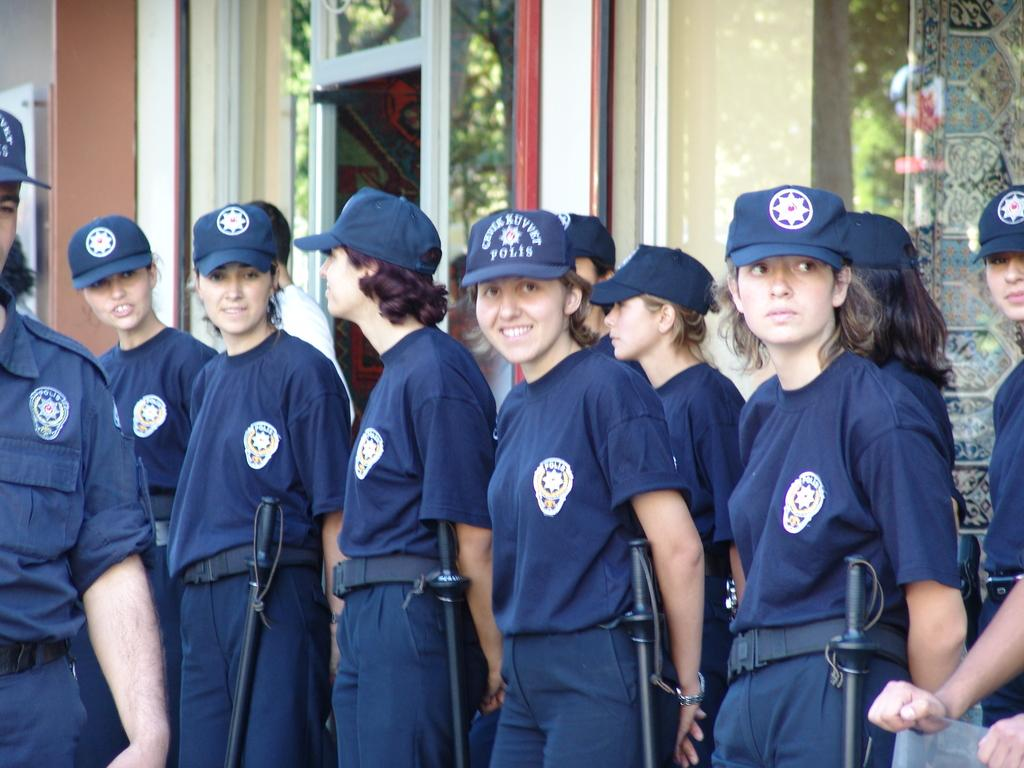What can be observed about the people in the image? There are people standing in the image, and they are wearing uniforms and caps. What is visible in the background of the image? There is a building in the background of the image. How does the image demonstrate the power of the people? The image does not demonstrate the power of the people; it simply shows them standing and wearing uniforms and caps. What is the level of noise in the image? The level of noise cannot be determined from the image, as it is a still photograph. 